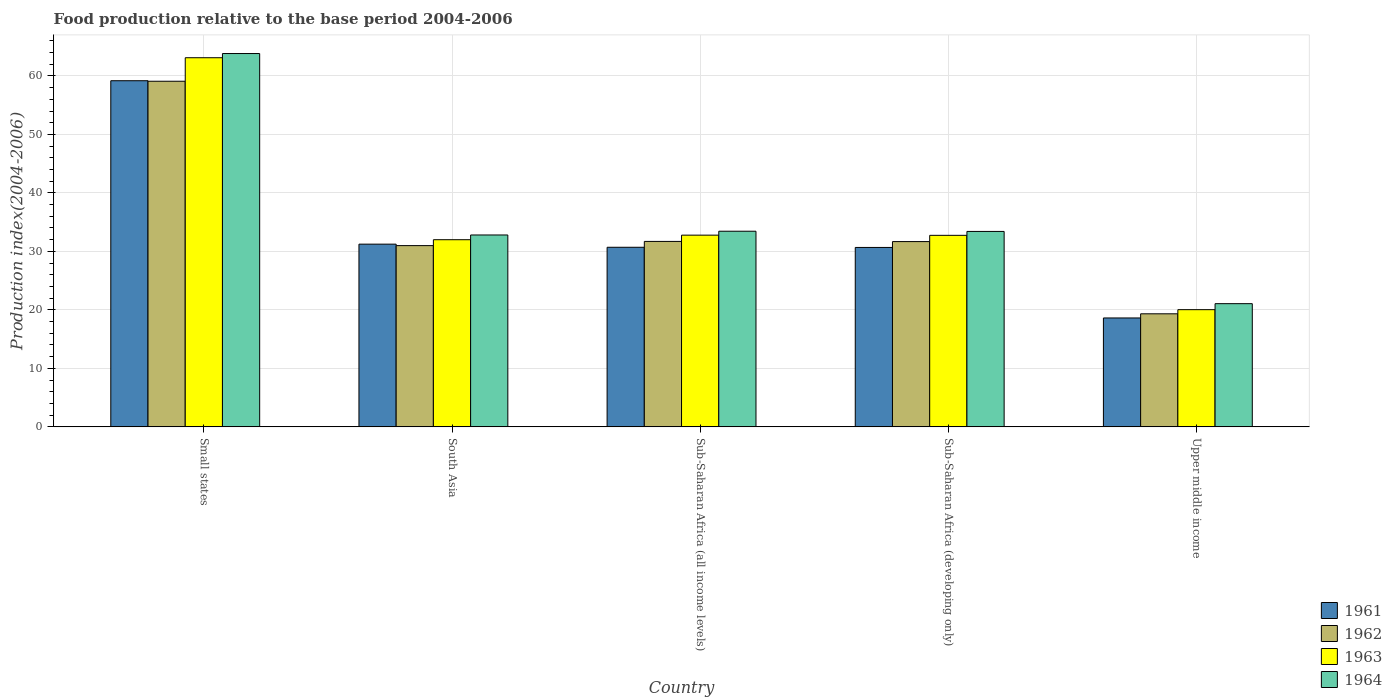How many different coloured bars are there?
Your answer should be compact. 4. Are the number of bars per tick equal to the number of legend labels?
Offer a terse response. Yes. How many bars are there on the 3rd tick from the right?
Keep it short and to the point. 4. What is the label of the 4th group of bars from the left?
Your response must be concise. Sub-Saharan Africa (developing only). What is the food production index in 1962 in South Asia?
Keep it short and to the point. 30.99. Across all countries, what is the maximum food production index in 1964?
Your answer should be very brief. 63.82. Across all countries, what is the minimum food production index in 1961?
Your answer should be very brief. 18.62. In which country was the food production index in 1961 maximum?
Your answer should be compact. Small states. In which country was the food production index in 1964 minimum?
Your response must be concise. Upper middle income. What is the total food production index in 1963 in the graph?
Make the answer very short. 180.66. What is the difference between the food production index in 1961 in Sub-Saharan Africa (all income levels) and that in Sub-Saharan Africa (developing only)?
Make the answer very short. 0.03. What is the difference between the food production index in 1964 in Small states and the food production index in 1961 in South Asia?
Give a very brief answer. 32.59. What is the average food production index in 1963 per country?
Your answer should be compact. 36.13. What is the difference between the food production index of/in 1962 and food production index of/in 1964 in Small states?
Ensure brevity in your answer.  -4.73. What is the ratio of the food production index in 1963 in Sub-Saharan Africa (all income levels) to that in Upper middle income?
Keep it short and to the point. 1.64. Is the food production index in 1964 in Small states less than that in Sub-Saharan Africa (all income levels)?
Ensure brevity in your answer.  No. What is the difference between the highest and the second highest food production index in 1964?
Ensure brevity in your answer.  0.04. What is the difference between the highest and the lowest food production index in 1964?
Make the answer very short. 42.76. Is the sum of the food production index in 1963 in South Asia and Sub-Saharan Africa (developing only) greater than the maximum food production index in 1962 across all countries?
Offer a terse response. Yes. Is it the case that in every country, the sum of the food production index in 1961 and food production index in 1962 is greater than the sum of food production index in 1964 and food production index in 1963?
Ensure brevity in your answer.  No. Is it the case that in every country, the sum of the food production index in 1963 and food production index in 1961 is greater than the food production index in 1962?
Give a very brief answer. Yes. Are all the bars in the graph horizontal?
Provide a short and direct response. No. Are the values on the major ticks of Y-axis written in scientific E-notation?
Offer a very short reply. No. Where does the legend appear in the graph?
Offer a terse response. Bottom right. What is the title of the graph?
Offer a terse response. Food production relative to the base period 2004-2006. Does "2009" appear as one of the legend labels in the graph?
Your response must be concise. No. What is the label or title of the Y-axis?
Your answer should be compact. Production index(2004-2006). What is the Production index(2004-2006) of 1961 in Small states?
Give a very brief answer. 59.17. What is the Production index(2004-2006) of 1962 in Small states?
Provide a succinct answer. 59.09. What is the Production index(2004-2006) in 1963 in Small states?
Keep it short and to the point. 63.11. What is the Production index(2004-2006) in 1964 in Small states?
Your answer should be compact. 63.82. What is the Production index(2004-2006) of 1961 in South Asia?
Give a very brief answer. 31.24. What is the Production index(2004-2006) of 1962 in South Asia?
Ensure brevity in your answer.  30.99. What is the Production index(2004-2006) of 1963 in South Asia?
Your answer should be very brief. 32. What is the Production index(2004-2006) of 1964 in South Asia?
Your answer should be compact. 32.8. What is the Production index(2004-2006) in 1961 in Sub-Saharan Africa (all income levels)?
Ensure brevity in your answer.  30.7. What is the Production index(2004-2006) in 1962 in Sub-Saharan Africa (all income levels)?
Provide a succinct answer. 31.71. What is the Production index(2004-2006) in 1963 in Sub-Saharan Africa (all income levels)?
Keep it short and to the point. 32.78. What is the Production index(2004-2006) in 1964 in Sub-Saharan Africa (all income levels)?
Provide a succinct answer. 33.45. What is the Production index(2004-2006) in 1961 in Sub-Saharan Africa (developing only)?
Give a very brief answer. 30.68. What is the Production index(2004-2006) of 1962 in Sub-Saharan Africa (developing only)?
Provide a succinct answer. 31.68. What is the Production index(2004-2006) in 1963 in Sub-Saharan Africa (developing only)?
Provide a succinct answer. 32.75. What is the Production index(2004-2006) of 1964 in Sub-Saharan Africa (developing only)?
Your response must be concise. 33.41. What is the Production index(2004-2006) in 1961 in Upper middle income?
Ensure brevity in your answer.  18.62. What is the Production index(2004-2006) of 1962 in Upper middle income?
Ensure brevity in your answer.  19.33. What is the Production index(2004-2006) in 1963 in Upper middle income?
Provide a succinct answer. 20.04. What is the Production index(2004-2006) in 1964 in Upper middle income?
Give a very brief answer. 21.06. Across all countries, what is the maximum Production index(2004-2006) of 1961?
Keep it short and to the point. 59.17. Across all countries, what is the maximum Production index(2004-2006) of 1962?
Provide a short and direct response. 59.09. Across all countries, what is the maximum Production index(2004-2006) of 1963?
Your answer should be very brief. 63.11. Across all countries, what is the maximum Production index(2004-2006) of 1964?
Ensure brevity in your answer.  63.82. Across all countries, what is the minimum Production index(2004-2006) in 1961?
Your response must be concise. 18.62. Across all countries, what is the minimum Production index(2004-2006) in 1962?
Make the answer very short. 19.33. Across all countries, what is the minimum Production index(2004-2006) of 1963?
Give a very brief answer. 20.04. Across all countries, what is the minimum Production index(2004-2006) of 1964?
Offer a very short reply. 21.06. What is the total Production index(2004-2006) in 1961 in the graph?
Offer a terse response. 170.41. What is the total Production index(2004-2006) of 1962 in the graph?
Ensure brevity in your answer.  172.78. What is the total Production index(2004-2006) of 1963 in the graph?
Provide a succinct answer. 180.66. What is the total Production index(2004-2006) of 1964 in the graph?
Ensure brevity in your answer.  184.55. What is the difference between the Production index(2004-2006) in 1961 in Small states and that in South Asia?
Make the answer very short. 27.94. What is the difference between the Production index(2004-2006) of 1962 in Small states and that in South Asia?
Provide a succinct answer. 28.1. What is the difference between the Production index(2004-2006) of 1963 in Small states and that in South Asia?
Your answer should be very brief. 31.11. What is the difference between the Production index(2004-2006) in 1964 in Small states and that in South Asia?
Provide a succinct answer. 31.02. What is the difference between the Production index(2004-2006) of 1961 in Small states and that in Sub-Saharan Africa (all income levels)?
Offer a terse response. 28.47. What is the difference between the Production index(2004-2006) in 1962 in Small states and that in Sub-Saharan Africa (all income levels)?
Your answer should be very brief. 27.38. What is the difference between the Production index(2004-2006) in 1963 in Small states and that in Sub-Saharan Africa (all income levels)?
Your answer should be very brief. 30.33. What is the difference between the Production index(2004-2006) of 1964 in Small states and that in Sub-Saharan Africa (all income levels)?
Your answer should be very brief. 30.38. What is the difference between the Production index(2004-2006) of 1961 in Small states and that in Sub-Saharan Africa (developing only)?
Offer a very short reply. 28.5. What is the difference between the Production index(2004-2006) of 1962 in Small states and that in Sub-Saharan Africa (developing only)?
Provide a succinct answer. 27.41. What is the difference between the Production index(2004-2006) of 1963 in Small states and that in Sub-Saharan Africa (developing only)?
Your response must be concise. 30.36. What is the difference between the Production index(2004-2006) in 1964 in Small states and that in Sub-Saharan Africa (developing only)?
Your answer should be compact. 30.41. What is the difference between the Production index(2004-2006) in 1961 in Small states and that in Upper middle income?
Your answer should be very brief. 40.55. What is the difference between the Production index(2004-2006) in 1962 in Small states and that in Upper middle income?
Give a very brief answer. 39.76. What is the difference between the Production index(2004-2006) of 1963 in Small states and that in Upper middle income?
Give a very brief answer. 43.07. What is the difference between the Production index(2004-2006) of 1964 in Small states and that in Upper middle income?
Make the answer very short. 42.76. What is the difference between the Production index(2004-2006) of 1961 in South Asia and that in Sub-Saharan Africa (all income levels)?
Ensure brevity in your answer.  0.54. What is the difference between the Production index(2004-2006) in 1962 in South Asia and that in Sub-Saharan Africa (all income levels)?
Your answer should be very brief. -0.72. What is the difference between the Production index(2004-2006) of 1963 in South Asia and that in Sub-Saharan Africa (all income levels)?
Make the answer very short. -0.78. What is the difference between the Production index(2004-2006) in 1964 in South Asia and that in Sub-Saharan Africa (all income levels)?
Offer a very short reply. -0.64. What is the difference between the Production index(2004-2006) in 1961 in South Asia and that in Sub-Saharan Africa (developing only)?
Make the answer very short. 0.56. What is the difference between the Production index(2004-2006) in 1962 in South Asia and that in Sub-Saharan Africa (developing only)?
Ensure brevity in your answer.  -0.69. What is the difference between the Production index(2004-2006) of 1963 in South Asia and that in Sub-Saharan Africa (developing only)?
Your response must be concise. -0.75. What is the difference between the Production index(2004-2006) of 1964 in South Asia and that in Sub-Saharan Africa (developing only)?
Ensure brevity in your answer.  -0.61. What is the difference between the Production index(2004-2006) in 1961 in South Asia and that in Upper middle income?
Offer a terse response. 12.62. What is the difference between the Production index(2004-2006) of 1962 in South Asia and that in Upper middle income?
Provide a succinct answer. 11.66. What is the difference between the Production index(2004-2006) in 1963 in South Asia and that in Upper middle income?
Offer a very short reply. 11.96. What is the difference between the Production index(2004-2006) in 1964 in South Asia and that in Upper middle income?
Keep it short and to the point. 11.74. What is the difference between the Production index(2004-2006) in 1961 in Sub-Saharan Africa (all income levels) and that in Sub-Saharan Africa (developing only)?
Offer a terse response. 0.03. What is the difference between the Production index(2004-2006) of 1962 in Sub-Saharan Africa (all income levels) and that in Sub-Saharan Africa (developing only)?
Provide a succinct answer. 0.03. What is the difference between the Production index(2004-2006) of 1963 in Sub-Saharan Africa (all income levels) and that in Sub-Saharan Africa (developing only)?
Your answer should be compact. 0.03. What is the difference between the Production index(2004-2006) in 1964 in Sub-Saharan Africa (all income levels) and that in Sub-Saharan Africa (developing only)?
Provide a short and direct response. 0.04. What is the difference between the Production index(2004-2006) in 1961 in Sub-Saharan Africa (all income levels) and that in Upper middle income?
Your answer should be very brief. 12.08. What is the difference between the Production index(2004-2006) in 1962 in Sub-Saharan Africa (all income levels) and that in Upper middle income?
Your response must be concise. 12.38. What is the difference between the Production index(2004-2006) of 1963 in Sub-Saharan Africa (all income levels) and that in Upper middle income?
Provide a succinct answer. 12.74. What is the difference between the Production index(2004-2006) of 1964 in Sub-Saharan Africa (all income levels) and that in Upper middle income?
Provide a succinct answer. 12.38. What is the difference between the Production index(2004-2006) of 1961 in Sub-Saharan Africa (developing only) and that in Upper middle income?
Make the answer very short. 12.06. What is the difference between the Production index(2004-2006) of 1962 in Sub-Saharan Africa (developing only) and that in Upper middle income?
Your answer should be very brief. 12.35. What is the difference between the Production index(2004-2006) in 1963 in Sub-Saharan Africa (developing only) and that in Upper middle income?
Offer a very short reply. 12.71. What is the difference between the Production index(2004-2006) of 1964 in Sub-Saharan Africa (developing only) and that in Upper middle income?
Provide a short and direct response. 12.35. What is the difference between the Production index(2004-2006) of 1961 in Small states and the Production index(2004-2006) of 1962 in South Asia?
Offer a very short reply. 28.19. What is the difference between the Production index(2004-2006) in 1961 in Small states and the Production index(2004-2006) in 1963 in South Asia?
Make the answer very short. 27.18. What is the difference between the Production index(2004-2006) in 1961 in Small states and the Production index(2004-2006) in 1964 in South Asia?
Ensure brevity in your answer.  26.37. What is the difference between the Production index(2004-2006) of 1962 in Small states and the Production index(2004-2006) of 1963 in South Asia?
Make the answer very short. 27.09. What is the difference between the Production index(2004-2006) of 1962 in Small states and the Production index(2004-2006) of 1964 in South Asia?
Your response must be concise. 26.28. What is the difference between the Production index(2004-2006) in 1963 in Small states and the Production index(2004-2006) in 1964 in South Asia?
Provide a succinct answer. 30.3. What is the difference between the Production index(2004-2006) in 1961 in Small states and the Production index(2004-2006) in 1962 in Sub-Saharan Africa (all income levels)?
Your answer should be compact. 27.47. What is the difference between the Production index(2004-2006) of 1961 in Small states and the Production index(2004-2006) of 1963 in Sub-Saharan Africa (all income levels)?
Offer a very short reply. 26.4. What is the difference between the Production index(2004-2006) of 1961 in Small states and the Production index(2004-2006) of 1964 in Sub-Saharan Africa (all income levels)?
Provide a succinct answer. 25.73. What is the difference between the Production index(2004-2006) in 1962 in Small states and the Production index(2004-2006) in 1963 in Sub-Saharan Africa (all income levels)?
Make the answer very short. 26.31. What is the difference between the Production index(2004-2006) in 1962 in Small states and the Production index(2004-2006) in 1964 in Sub-Saharan Africa (all income levels)?
Provide a short and direct response. 25.64. What is the difference between the Production index(2004-2006) of 1963 in Small states and the Production index(2004-2006) of 1964 in Sub-Saharan Africa (all income levels)?
Provide a short and direct response. 29.66. What is the difference between the Production index(2004-2006) of 1961 in Small states and the Production index(2004-2006) of 1962 in Sub-Saharan Africa (developing only)?
Your answer should be very brief. 27.5. What is the difference between the Production index(2004-2006) of 1961 in Small states and the Production index(2004-2006) of 1963 in Sub-Saharan Africa (developing only)?
Make the answer very short. 26.43. What is the difference between the Production index(2004-2006) of 1961 in Small states and the Production index(2004-2006) of 1964 in Sub-Saharan Africa (developing only)?
Ensure brevity in your answer.  25.76. What is the difference between the Production index(2004-2006) in 1962 in Small states and the Production index(2004-2006) in 1963 in Sub-Saharan Africa (developing only)?
Provide a succinct answer. 26.34. What is the difference between the Production index(2004-2006) of 1962 in Small states and the Production index(2004-2006) of 1964 in Sub-Saharan Africa (developing only)?
Keep it short and to the point. 25.68. What is the difference between the Production index(2004-2006) in 1963 in Small states and the Production index(2004-2006) in 1964 in Sub-Saharan Africa (developing only)?
Provide a succinct answer. 29.7. What is the difference between the Production index(2004-2006) of 1961 in Small states and the Production index(2004-2006) of 1962 in Upper middle income?
Give a very brief answer. 39.85. What is the difference between the Production index(2004-2006) of 1961 in Small states and the Production index(2004-2006) of 1963 in Upper middle income?
Provide a short and direct response. 39.14. What is the difference between the Production index(2004-2006) of 1961 in Small states and the Production index(2004-2006) of 1964 in Upper middle income?
Provide a succinct answer. 38.11. What is the difference between the Production index(2004-2006) in 1962 in Small states and the Production index(2004-2006) in 1963 in Upper middle income?
Your answer should be very brief. 39.05. What is the difference between the Production index(2004-2006) in 1962 in Small states and the Production index(2004-2006) in 1964 in Upper middle income?
Offer a very short reply. 38.03. What is the difference between the Production index(2004-2006) in 1963 in Small states and the Production index(2004-2006) in 1964 in Upper middle income?
Make the answer very short. 42.05. What is the difference between the Production index(2004-2006) in 1961 in South Asia and the Production index(2004-2006) in 1962 in Sub-Saharan Africa (all income levels)?
Your response must be concise. -0.47. What is the difference between the Production index(2004-2006) in 1961 in South Asia and the Production index(2004-2006) in 1963 in Sub-Saharan Africa (all income levels)?
Your answer should be compact. -1.54. What is the difference between the Production index(2004-2006) in 1961 in South Asia and the Production index(2004-2006) in 1964 in Sub-Saharan Africa (all income levels)?
Make the answer very short. -2.21. What is the difference between the Production index(2004-2006) of 1962 in South Asia and the Production index(2004-2006) of 1963 in Sub-Saharan Africa (all income levels)?
Ensure brevity in your answer.  -1.79. What is the difference between the Production index(2004-2006) of 1962 in South Asia and the Production index(2004-2006) of 1964 in Sub-Saharan Africa (all income levels)?
Provide a short and direct response. -2.46. What is the difference between the Production index(2004-2006) of 1963 in South Asia and the Production index(2004-2006) of 1964 in Sub-Saharan Africa (all income levels)?
Provide a short and direct response. -1.45. What is the difference between the Production index(2004-2006) in 1961 in South Asia and the Production index(2004-2006) in 1962 in Sub-Saharan Africa (developing only)?
Ensure brevity in your answer.  -0.44. What is the difference between the Production index(2004-2006) of 1961 in South Asia and the Production index(2004-2006) of 1963 in Sub-Saharan Africa (developing only)?
Your answer should be compact. -1.51. What is the difference between the Production index(2004-2006) of 1961 in South Asia and the Production index(2004-2006) of 1964 in Sub-Saharan Africa (developing only)?
Provide a succinct answer. -2.17. What is the difference between the Production index(2004-2006) of 1962 in South Asia and the Production index(2004-2006) of 1963 in Sub-Saharan Africa (developing only)?
Your answer should be compact. -1.76. What is the difference between the Production index(2004-2006) in 1962 in South Asia and the Production index(2004-2006) in 1964 in Sub-Saharan Africa (developing only)?
Give a very brief answer. -2.43. What is the difference between the Production index(2004-2006) in 1963 in South Asia and the Production index(2004-2006) in 1964 in Sub-Saharan Africa (developing only)?
Make the answer very short. -1.42. What is the difference between the Production index(2004-2006) of 1961 in South Asia and the Production index(2004-2006) of 1962 in Upper middle income?
Your answer should be compact. 11.91. What is the difference between the Production index(2004-2006) in 1961 in South Asia and the Production index(2004-2006) in 1963 in Upper middle income?
Ensure brevity in your answer.  11.2. What is the difference between the Production index(2004-2006) in 1961 in South Asia and the Production index(2004-2006) in 1964 in Upper middle income?
Give a very brief answer. 10.18. What is the difference between the Production index(2004-2006) of 1962 in South Asia and the Production index(2004-2006) of 1963 in Upper middle income?
Make the answer very short. 10.95. What is the difference between the Production index(2004-2006) of 1962 in South Asia and the Production index(2004-2006) of 1964 in Upper middle income?
Provide a short and direct response. 9.92. What is the difference between the Production index(2004-2006) in 1963 in South Asia and the Production index(2004-2006) in 1964 in Upper middle income?
Your answer should be very brief. 10.93. What is the difference between the Production index(2004-2006) in 1961 in Sub-Saharan Africa (all income levels) and the Production index(2004-2006) in 1962 in Sub-Saharan Africa (developing only)?
Your answer should be very brief. -0.97. What is the difference between the Production index(2004-2006) in 1961 in Sub-Saharan Africa (all income levels) and the Production index(2004-2006) in 1963 in Sub-Saharan Africa (developing only)?
Ensure brevity in your answer.  -2.04. What is the difference between the Production index(2004-2006) in 1961 in Sub-Saharan Africa (all income levels) and the Production index(2004-2006) in 1964 in Sub-Saharan Africa (developing only)?
Your answer should be very brief. -2.71. What is the difference between the Production index(2004-2006) in 1962 in Sub-Saharan Africa (all income levels) and the Production index(2004-2006) in 1963 in Sub-Saharan Africa (developing only)?
Make the answer very short. -1.04. What is the difference between the Production index(2004-2006) in 1962 in Sub-Saharan Africa (all income levels) and the Production index(2004-2006) in 1964 in Sub-Saharan Africa (developing only)?
Offer a very short reply. -1.71. What is the difference between the Production index(2004-2006) in 1963 in Sub-Saharan Africa (all income levels) and the Production index(2004-2006) in 1964 in Sub-Saharan Africa (developing only)?
Provide a short and direct response. -0.63. What is the difference between the Production index(2004-2006) of 1961 in Sub-Saharan Africa (all income levels) and the Production index(2004-2006) of 1962 in Upper middle income?
Keep it short and to the point. 11.37. What is the difference between the Production index(2004-2006) in 1961 in Sub-Saharan Africa (all income levels) and the Production index(2004-2006) in 1963 in Upper middle income?
Keep it short and to the point. 10.66. What is the difference between the Production index(2004-2006) in 1961 in Sub-Saharan Africa (all income levels) and the Production index(2004-2006) in 1964 in Upper middle income?
Ensure brevity in your answer.  9.64. What is the difference between the Production index(2004-2006) of 1962 in Sub-Saharan Africa (all income levels) and the Production index(2004-2006) of 1963 in Upper middle income?
Provide a short and direct response. 11.67. What is the difference between the Production index(2004-2006) of 1962 in Sub-Saharan Africa (all income levels) and the Production index(2004-2006) of 1964 in Upper middle income?
Ensure brevity in your answer.  10.64. What is the difference between the Production index(2004-2006) in 1963 in Sub-Saharan Africa (all income levels) and the Production index(2004-2006) in 1964 in Upper middle income?
Keep it short and to the point. 11.71. What is the difference between the Production index(2004-2006) of 1961 in Sub-Saharan Africa (developing only) and the Production index(2004-2006) of 1962 in Upper middle income?
Offer a terse response. 11.35. What is the difference between the Production index(2004-2006) of 1961 in Sub-Saharan Africa (developing only) and the Production index(2004-2006) of 1963 in Upper middle income?
Your answer should be very brief. 10.64. What is the difference between the Production index(2004-2006) in 1961 in Sub-Saharan Africa (developing only) and the Production index(2004-2006) in 1964 in Upper middle income?
Keep it short and to the point. 9.61. What is the difference between the Production index(2004-2006) in 1962 in Sub-Saharan Africa (developing only) and the Production index(2004-2006) in 1963 in Upper middle income?
Keep it short and to the point. 11.64. What is the difference between the Production index(2004-2006) of 1962 in Sub-Saharan Africa (developing only) and the Production index(2004-2006) of 1964 in Upper middle income?
Your answer should be very brief. 10.61. What is the difference between the Production index(2004-2006) in 1963 in Sub-Saharan Africa (developing only) and the Production index(2004-2006) in 1964 in Upper middle income?
Your response must be concise. 11.68. What is the average Production index(2004-2006) in 1961 per country?
Your answer should be very brief. 34.08. What is the average Production index(2004-2006) of 1962 per country?
Give a very brief answer. 34.56. What is the average Production index(2004-2006) of 1963 per country?
Ensure brevity in your answer.  36.13. What is the average Production index(2004-2006) of 1964 per country?
Your answer should be very brief. 36.91. What is the difference between the Production index(2004-2006) in 1961 and Production index(2004-2006) in 1962 in Small states?
Offer a very short reply. 0.09. What is the difference between the Production index(2004-2006) in 1961 and Production index(2004-2006) in 1963 in Small states?
Provide a short and direct response. -3.93. What is the difference between the Production index(2004-2006) in 1961 and Production index(2004-2006) in 1964 in Small states?
Make the answer very short. -4.65. What is the difference between the Production index(2004-2006) of 1962 and Production index(2004-2006) of 1963 in Small states?
Your answer should be very brief. -4.02. What is the difference between the Production index(2004-2006) of 1962 and Production index(2004-2006) of 1964 in Small states?
Provide a short and direct response. -4.73. What is the difference between the Production index(2004-2006) in 1963 and Production index(2004-2006) in 1964 in Small states?
Keep it short and to the point. -0.72. What is the difference between the Production index(2004-2006) in 1961 and Production index(2004-2006) in 1962 in South Asia?
Your answer should be very brief. 0.25. What is the difference between the Production index(2004-2006) of 1961 and Production index(2004-2006) of 1963 in South Asia?
Offer a terse response. -0.76. What is the difference between the Production index(2004-2006) of 1961 and Production index(2004-2006) of 1964 in South Asia?
Provide a short and direct response. -1.57. What is the difference between the Production index(2004-2006) in 1962 and Production index(2004-2006) in 1963 in South Asia?
Give a very brief answer. -1.01. What is the difference between the Production index(2004-2006) in 1962 and Production index(2004-2006) in 1964 in South Asia?
Offer a very short reply. -1.82. What is the difference between the Production index(2004-2006) in 1963 and Production index(2004-2006) in 1964 in South Asia?
Your answer should be compact. -0.81. What is the difference between the Production index(2004-2006) of 1961 and Production index(2004-2006) of 1962 in Sub-Saharan Africa (all income levels)?
Offer a terse response. -1. What is the difference between the Production index(2004-2006) in 1961 and Production index(2004-2006) in 1963 in Sub-Saharan Africa (all income levels)?
Offer a very short reply. -2.08. What is the difference between the Production index(2004-2006) of 1961 and Production index(2004-2006) of 1964 in Sub-Saharan Africa (all income levels)?
Offer a very short reply. -2.74. What is the difference between the Production index(2004-2006) in 1962 and Production index(2004-2006) in 1963 in Sub-Saharan Africa (all income levels)?
Offer a terse response. -1.07. What is the difference between the Production index(2004-2006) in 1962 and Production index(2004-2006) in 1964 in Sub-Saharan Africa (all income levels)?
Offer a very short reply. -1.74. What is the difference between the Production index(2004-2006) in 1963 and Production index(2004-2006) in 1964 in Sub-Saharan Africa (all income levels)?
Your answer should be very brief. -0.67. What is the difference between the Production index(2004-2006) in 1961 and Production index(2004-2006) in 1962 in Sub-Saharan Africa (developing only)?
Offer a terse response. -1. What is the difference between the Production index(2004-2006) in 1961 and Production index(2004-2006) in 1963 in Sub-Saharan Africa (developing only)?
Provide a short and direct response. -2.07. What is the difference between the Production index(2004-2006) in 1961 and Production index(2004-2006) in 1964 in Sub-Saharan Africa (developing only)?
Make the answer very short. -2.74. What is the difference between the Production index(2004-2006) in 1962 and Production index(2004-2006) in 1963 in Sub-Saharan Africa (developing only)?
Your answer should be very brief. -1.07. What is the difference between the Production index(2004-2006) in 1962 and Production index(2004-2006) in 1964 in Sub-Saharan Africa (developing only)?
Offer a very short reply. -1.74. What is the difference between the Production index(2004-2006) of 1961 and Production index(2004-2006) of 1962 in Upper middle income?
Offer a very short reply. -0.71. What is the difference between the Production index(2004-2006) in 1961 and Production index(2004-2006) in 1963 in Upper middle income?
Provide a succinct answer. -1.42. What is the difference between the Production index(2004-2006) in 1961 and Production index(2004-2006) in 1964 in Upper middle income?
Keep it short and to the point. -2.44. What is the difference between the Production index(2004-2006) of 1962 and Production index(2004-2006) of 1963 in Upper middle income?
Ensure brevity in your answer.  -0.71. What is the difference between the Production index(2004-2006) of 1962 and Production index(2004-2006) of 1964 in Upper middle income?
Make the answer very short. -1.73. What is the difference between the Production index(2004-2006) of 1963 and Production index(2004-2006) of 1964 in Upper middle income?
Your answer should be very brief. -1.02. What is the ratio of the Production index(2004-2006) of 1961 in Small states to that in South Asia?
Provide a short and direct response. 1.89. What is the ratio of the Production index(2004-2006) of 1962 in Small states to that in South Asia?
Give a very brief answer. 1.91. What is the ratio of the Production index(2004-2006) in 1963 in Small states to that in South Asia?
Offer a terse response. 1.97. What is the ratio of the Production index(2004-2006) in 1964 in Small states to that in South Asia?
Your answer should be compact. 1.95. What is the ratio of the Production index(2004-2006) of 1961 in Small states to that in Sub-Saharan Africa (all income levels)?
Your answer should be compact. 1.93. What is the ratio of the Production index(2004-2006) of 1962 in Small states to that in Sub-Saharan Africa (all income levels)?
Ensure brevity in your answer.  1.86. What is the ratio of the Production index(2004-2006) of 1963 in Small states to that in Sub-Saharan Africa (all income levels)?
Offer a terse response. 1.93. What is the ratio of the Production index(2004-2006) of 1964 in Small states to that in Sub-Saharan Africa (all income levels)?
Make the answer very short. 1.91. What is the ratio of the Production index(2004-2006) in 1961 in Small states to that in Sub-Saharan Africa (developing only)?
Provide a short and direct response. 1.93. What is the ratio of the Production index(2004-2006) in 1962 in Small states to that in Sub-Saharan Africa (developing only)?
Offer a very short reply. 1.87. What is the ratio of the Production index(2004-2006) of 1963 in Small states to that in Sub-Saharan Africa (developing only)?
Ensure brevity in your answer.  1.93. What is the ratio of the Production index(2004-2006) of 1964 in Small states to that in Sub-Saharan Africa (developing only)?
Make the answer very short. 1.91. What is the ratio of the Production index(2004-2006) in 1961 in Small states to that in Upper middle income?
Ensure brevity in your answer.  3.18. What is the ratio of the Production index(2004-2006) in 1962 in Small states to that in Upper middle income?
Offer a terse response. 3.06. What is the ratio of the Production index(2004-2006) in 1963 in Small states to that in Upper middle income?
Ensure brevity in your answer.  3.15. What is the ratio of the Production index(2004-2006) in 1964 in Small states to that in Upper middle income?
Your answer should be compact. 3.03. What is the ratio of the Production index(2004-2006) in 1961 in South Asia to that in Sub-Saharan Africa (all income levels)?
Provide a short and direct response. 1.02. What is the ratio of the Production index(2004-2006) of 1962 in South Asia to that in Sub-Saharan Africa (all income levels)?
Provide a succinct answer. 0.98. What is the ratio of the Production index(2004-2006) in 1963 in South Asia to that in Sub-Saharan Africa (all income levels)?
Your answer should be very brief. 0.98. What is the ratio of the Production index(2004-2006) in 1964 in South Asia to that in Sub-Saharan Africa (all income levels)?
Give a very brief answer. 0.98. What is the ratio of the Production index(2004-2006) of 1961 in South Asia to that in Sub-Saharan Africa (developing only)?
Keep it short and to the point. 1.02. What is the ratio of the Production index(2004-2006) of 1962 in South Asia to that in Sub-Saharan Africa (developing only)?
Make the answer very short. 0.98. What is the ratio of the Production index(2004-2006) of 1963 in South Asia to that in Sub-Saharan Africa (developing only)?
Your response must be concise. 0.98. What is the ratio of the Production index(2004-2006) of 1964 in South Asia to that in Sub-Saharan Africa (developing only)?
Make the answer very short. 0.98. What is the ratio of the Production index(2004-2006) in 1961 in South Asia to that in Upper middle income?
Your answer should be very brief. 1.68. What is the ratio of the Production index(2004-2006) in 1962 in South Asia to that in Upper middle income?
Your answer should be very brief. 1.6. What is the ratio of the Production index(2004-2006) of 1963 in South Asia to that in Upper middle income?
Your answer should be compact. 1.6. What is the ratio of the Production index(2004-2006) in 1964 in South Asia to that in Upper middle income?
Ensure brevity in your answer.  1.56. What is the ratio of the Production index(2004-2006) in 1961 in Sub-Saharan Africa (all income levels) to that in Sub-Saharan Africa (developing only)?
Provide a short and direct response. 1. What is the ratio of the Production index(2004-2006) of 1963 in Sub-Saharan Africa (all income levels) to that in Sub-Saharan Africa (developing only)?
Give a very brief answer. 1. What is the ratio of the Production index(2004-2006) of 1961 in Sub-Saharan Africa (all income levels) to that in Upper middle income?
Provide a succinct answer. 1.65. What is the ratio of the Production index(2004-2006) of 1962 in Sub-Saharan Africa (all income levels) to that in Upper middle income?
Offer a terse response. 1.64. What is the ratio of the Production index(2004-2006) in 1963 in Sub-Saharan Africa (all income levels) to that in Upper middle income?
Make the answer very short. 1.64. What is the ratio of the Production index(2004-2006) of 1964 in Sub-Saharan Africa (all income levels) to that in Upper middle income?
Offer a terse response. 1.59. What is the ratio of the Production index(2004-2006) of 1961 in Sub-Saharan Africa (developing only) to that in Upper middle income?
Make the answer very short. 1.65. What is the ratio of the Production index(2004-2006) in 1962 in Sub-Saharan Africa (developing only) to that in Upper middle income?
Ensure brevity in your answer.  1.64. What is the ratio of the Production index(2004-2006) in 1963 in Sub-Saharan Africa (developing only) to that in Upper middle income?
Provide a short and direct response. 1.63. What is the ratio of the Production index(2004-2006) of 1964 in Sub-Saharan Africa (developing only) to that in Upper middle income?
Offer a terse response. 1.59. What is the difference between the highest and the second highest Production index(2004-2006) in 1961?
Provide a short and direct response. 27.94. What is the difference between the highest and the second highest Production index(2004-2006) of 1962?
Your response must be concise. 27.38. What is the difference between the highest and the second highest Production index(2004-2006) in 1963?
Offer a terse response. 30.33. What is the difference between the highest and the second highest Production index(2004-2006) of 1964?
Your response must be concise. 30.38. What is the difference between the highest and the lowest Production index(2004-2006) of 1961?
Your response must be concise. 40.55. What is the difference between the highest and the lowest Production index(2004-2006) in 1962?
Your answer should be compact. 39.76. What is the difference between the highest and the lowest Production index(2004-2006) in 1963?
Provide a short and direct response. 43.07. What is the difference between the highest and the lowest Production index(2004-2006) in 1964?
Your answer should be compact. 42.76. 